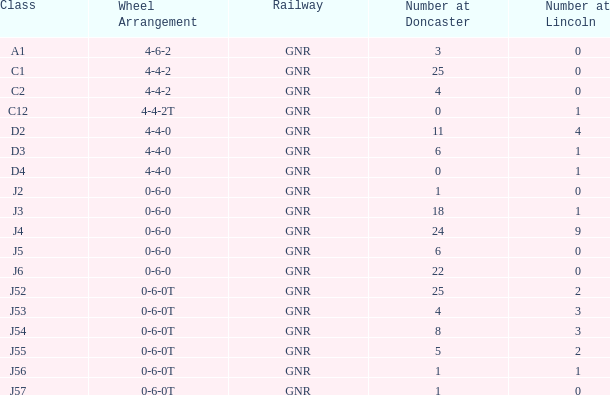What class in lincoln features a number under 1 and a 0-6-0 wheel layout? J2, J5, J6. 